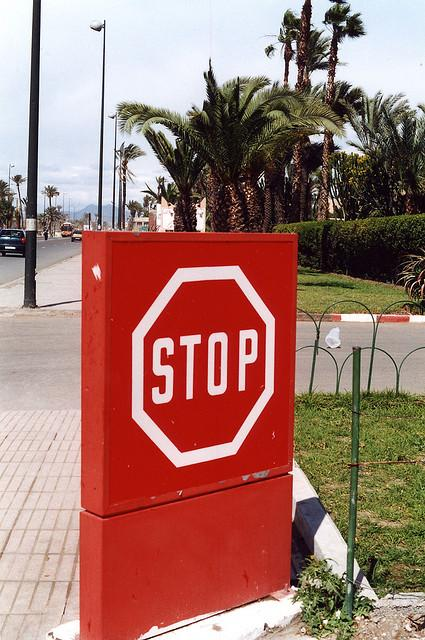Where can we find the sign above? road 